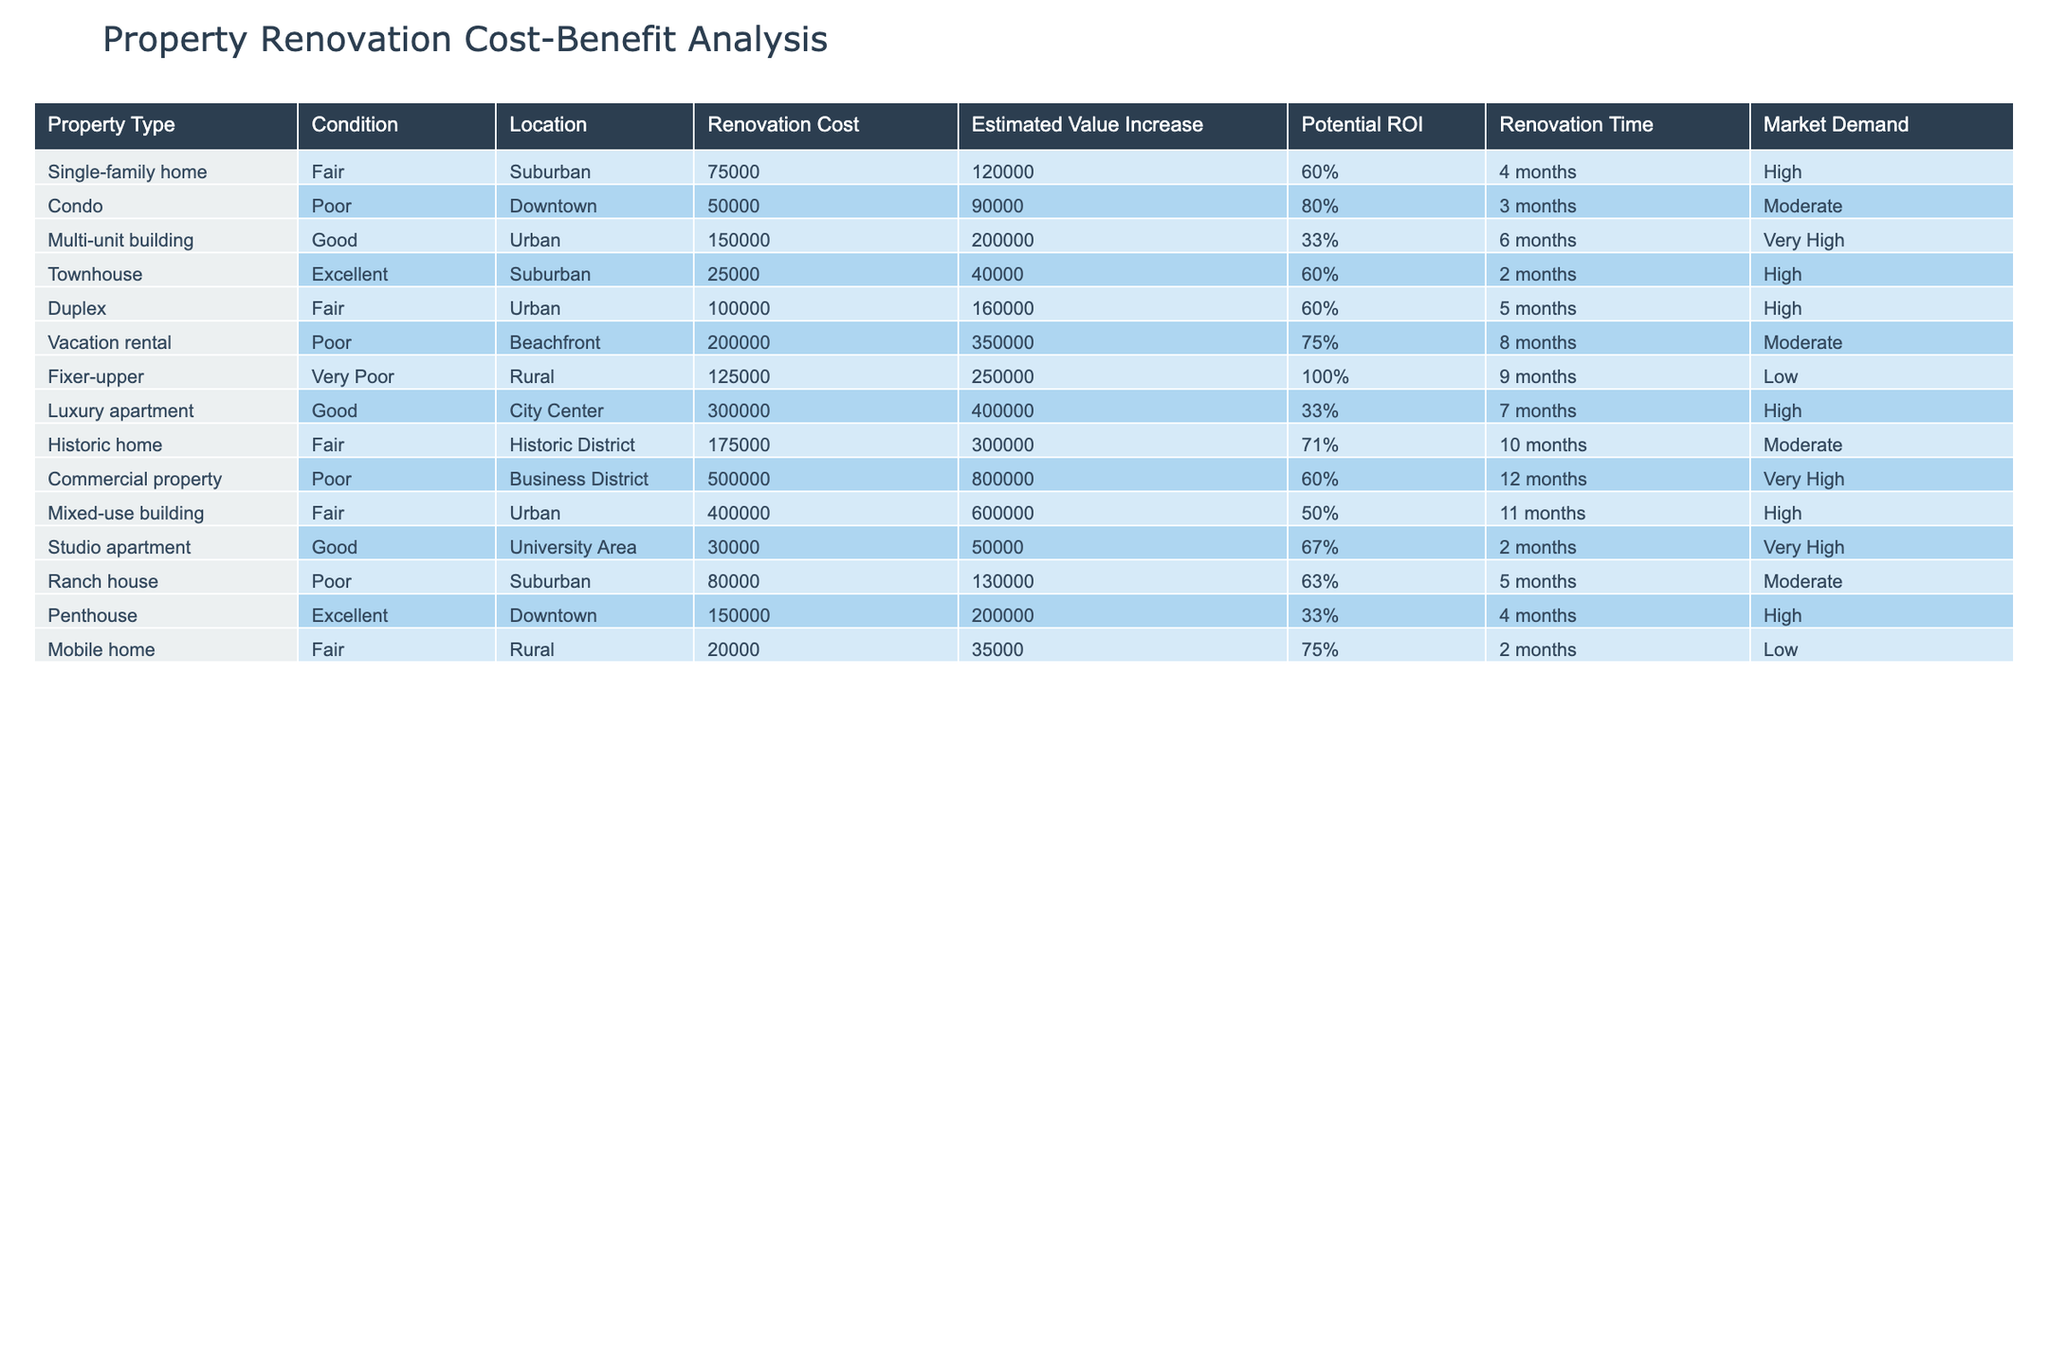What is the renovation cost for a vacation rental? The table lists the renovation costs for each property type. For the vacation rental, the renovation cost is specifically mentioned as 200,000.
Answer: 200000 Which property type has the highest estimated value increase? Each property type's estimated value increase is given in the table. Scanning through the values, the fixer-upper has the highest estimated value increase at 250,000.
Answer: 250000 Is the potential ROI for a townhouse greater than 60%? The potential ROI for the townhouse is listed as 60%. Since the question is asking if it's greater than this value, we conclude it's not true, as it equals 60%.
Answer: No What property types have a renovation time of less than 3 months? Looking at the renovation time column, we can see the townhouse and studio apartment both have renovation times listed at 2 months, which is less than 3 months.
Answer: Townhouse, Studio apartment What is the average renovation cost for properties with a 'Good' condition? The renovation costs for properties marked as 'Good' are the studio apartment (30,000), multi-unit building (150,000), and luxury apartment (300,000). Adding these gives 30,000 + 150,000 + 300,000 = 480,000. We then divide by the count of good condition properties, which is 3, resulting in an average renovation cost of 480,000 / 3 = 160,000.
Answer: 160000 How many property types have market demand rated as 'High'? Four property types listed have a market demand rated as 'High': single-family home, townhouse, duplex, and mixed-use building. So, the count is 4.
Answer: 4 Is the renovation cost for a fixer-upper lower than that of a multi-unit building? The renovation cost for the fixer-upper is 125,000, while for the multi-unit building, it is 150,000. Since 125,000 is indeed lower than 150,000, this statement is true.
Answer: Yes What is the total estimated value increase for commercial properties listed in the table? The table indicates that the commercial property has an estimated value increase of 800,000. Since it is the only commercial property listed, the total estimated value increase is simply 800,000.
Answer: 800000 